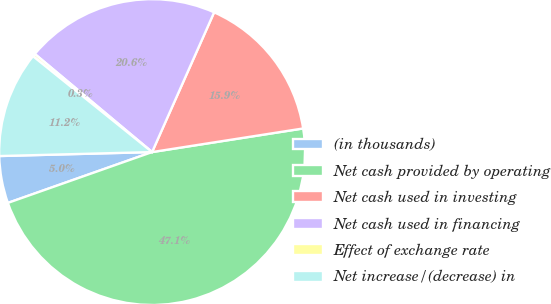<chart> <loc_0><loc_0><loc_500><loc_500><pie_chart><fcel>(in thousands)<fcel>Net cash provided by operating<fcel>Net cash used in investing<fcel>Net cash used in financing<fcel>Effect of exchange rate<fcel>Net increase/(decrease) in<nl><fcel>4.98%<fcel>47.07%<fcel>15.88%<fcel>20.56%<fcel>0.3%<fcel>11.2%<nl></chart> 